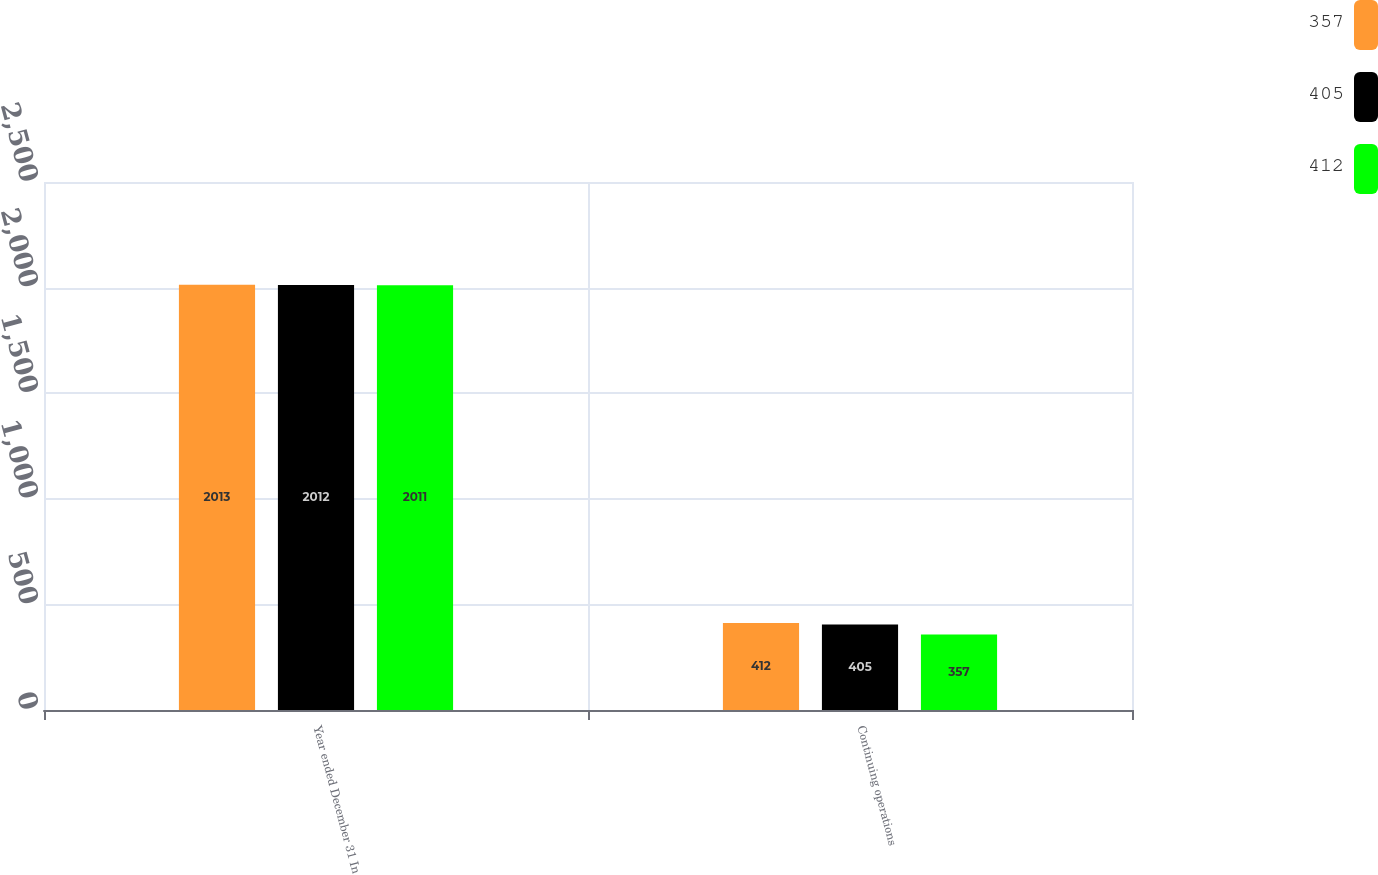<chart> <loc_0><loc_0><loc_500><loc_500><stacked_bar_chart><ecel><fcel>Year ended December 31 In<fcel>Continuing operations<nl><fcel>357<fcel>2013<fcel>412<nl><fcel>405<fcel>2012<fcel>405<nl><fcel>412<fcel>2011<fcel>357<nl></chart> 